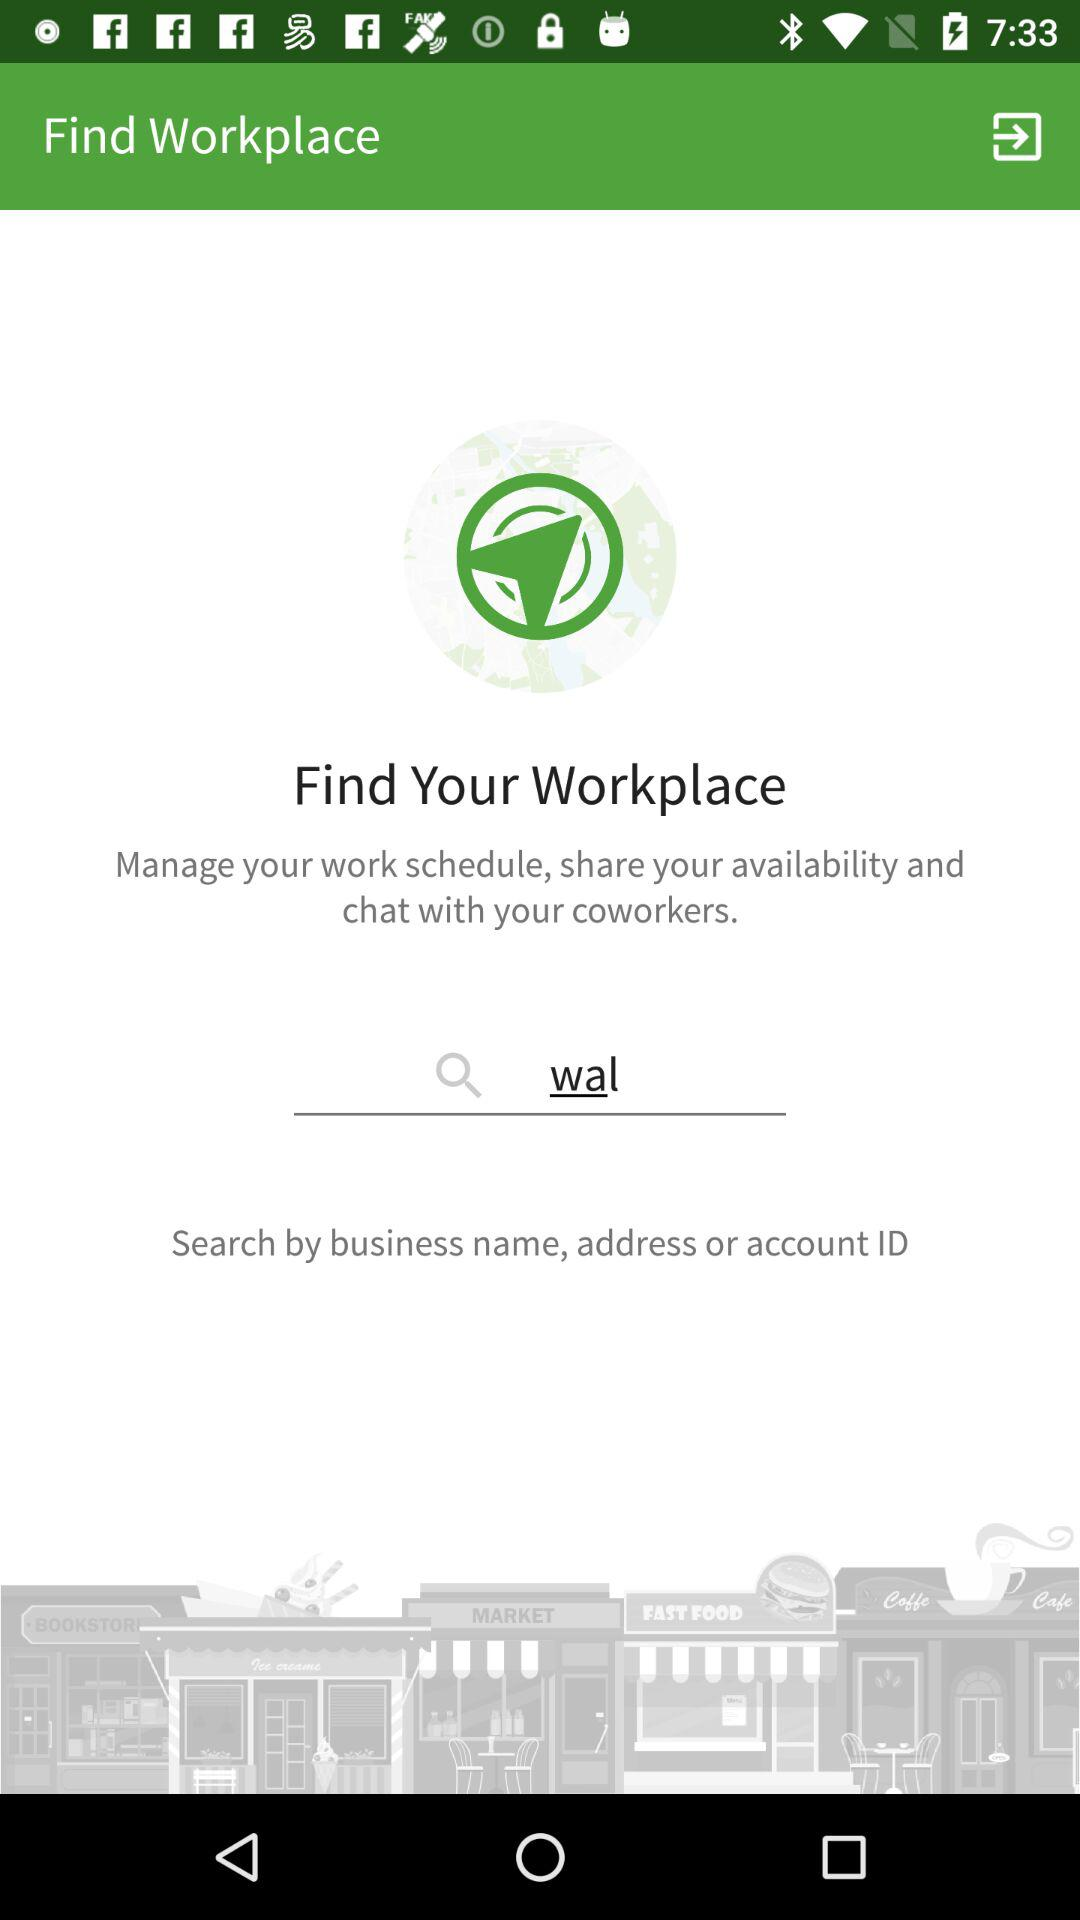By what keywords can a workplace be searched? A workplace can be searched by business name, address or account ID. 